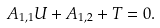Convert formula to latex. <formula><loc_0><loc_0><loc_500><loc_500>A _ { 1 , 1 } U + A _ { 1 , 2 } + T = 0 .</formula> 